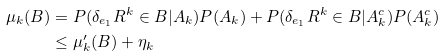Convert formula to latex. <formula><loc_0><loc_0><loc_500><loc_500>\mu _ { k } ( B ) & = P ( \delta _ { e _ { 1 } } R ^ { k } \in B | A _ { k } ) P ( A _ { k } ) + P ( \delta _ { e _ { 1 } } R ^ { k } \in B | A _ { k } ^ { c } ) P ( A _ { k } ^ { c } ) \\ & \leq \mu _ { k } ^ { \prime } ( B ) + \eta _ { k }</formula> 